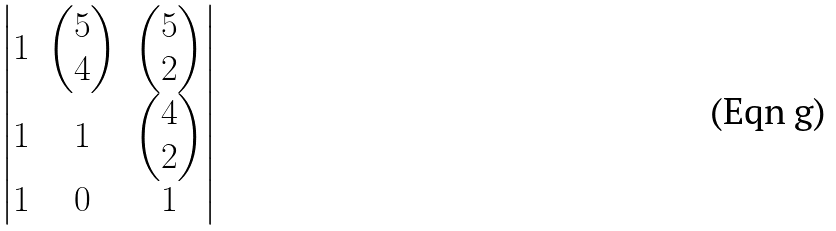<formula> <loc_0><loc_0><loc_500><loc_500>\begin{vmatrix} 1 & \begin{pmatrix} 5 \\ 4 \end{pmatrix} & \begin{pmatrix} 5 \\ 2 \end{pmatrix} \\ 1 & 1 & \begin{pmatrix} 4 \\ 2 \end{pmatrix} \\ 1 & 0 & 1 \end{vmatrix}</formula> 